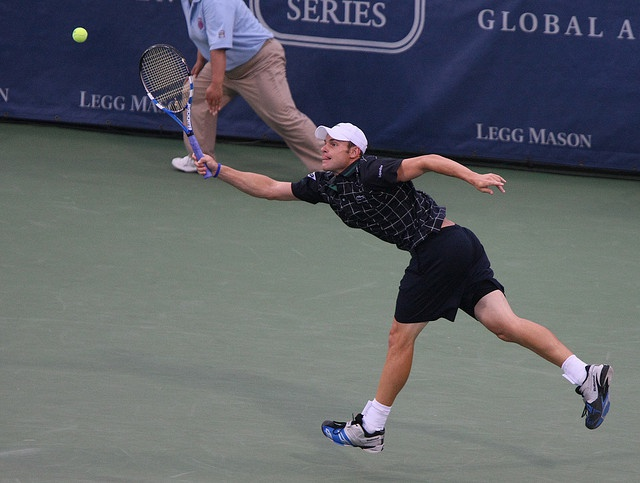Describe the objects in this image and their specific colors. I can see people in navy, black, brown, gray, and lightpink tones, people in navy, gray, and darkgray tones, tennis racket in navy, gray, black, and darkgray tones, and sports ball in navy, khaki, and olive tones in this image. 